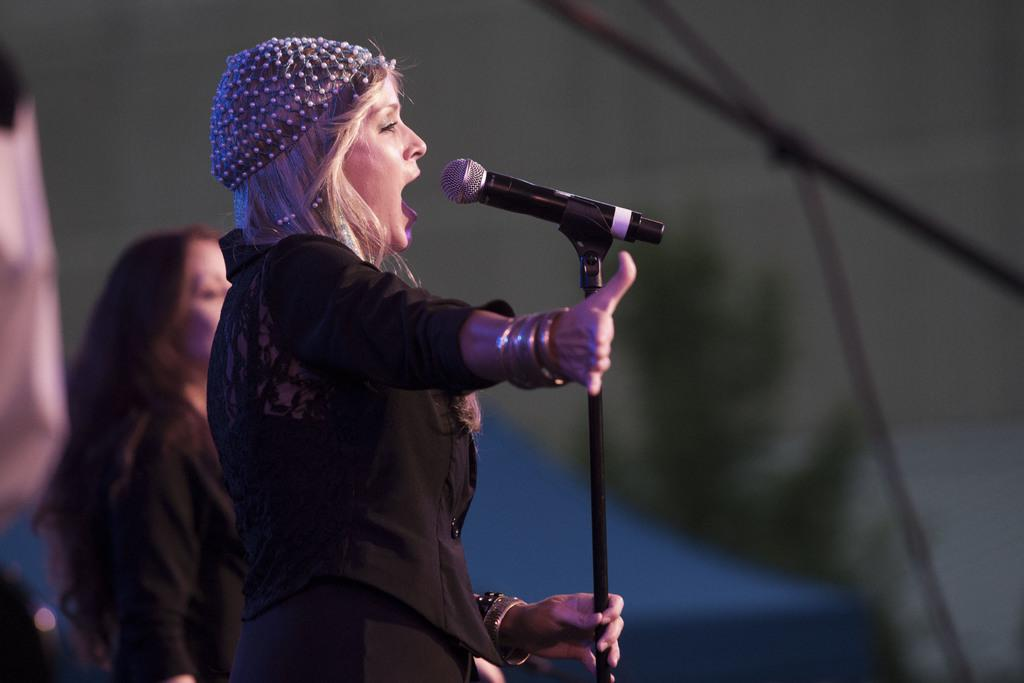What is the main subject of the image? The main subject of the image is a person standing in front of a mic. Can you describe the position of the person in the image? The person is standing in front of a mic. Are there any other people visible in the image? Yes, there is another person to the side of the first person. What type of arithmetic problem is the person solving in the image? There is no arithmetic problem visible in the image. Is the person talking into the mic in the image? The image does not show the person talking into the mic, only standing in front of it. 